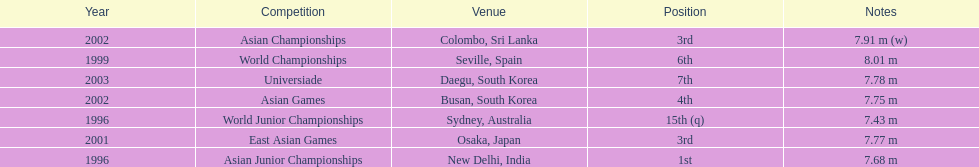When was the 3rd position first reached in a specific year? 2001. 